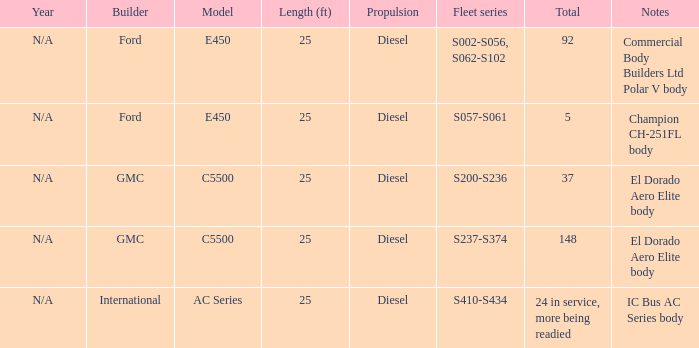Which model with a fleet series of s410-s434? AC Series. 